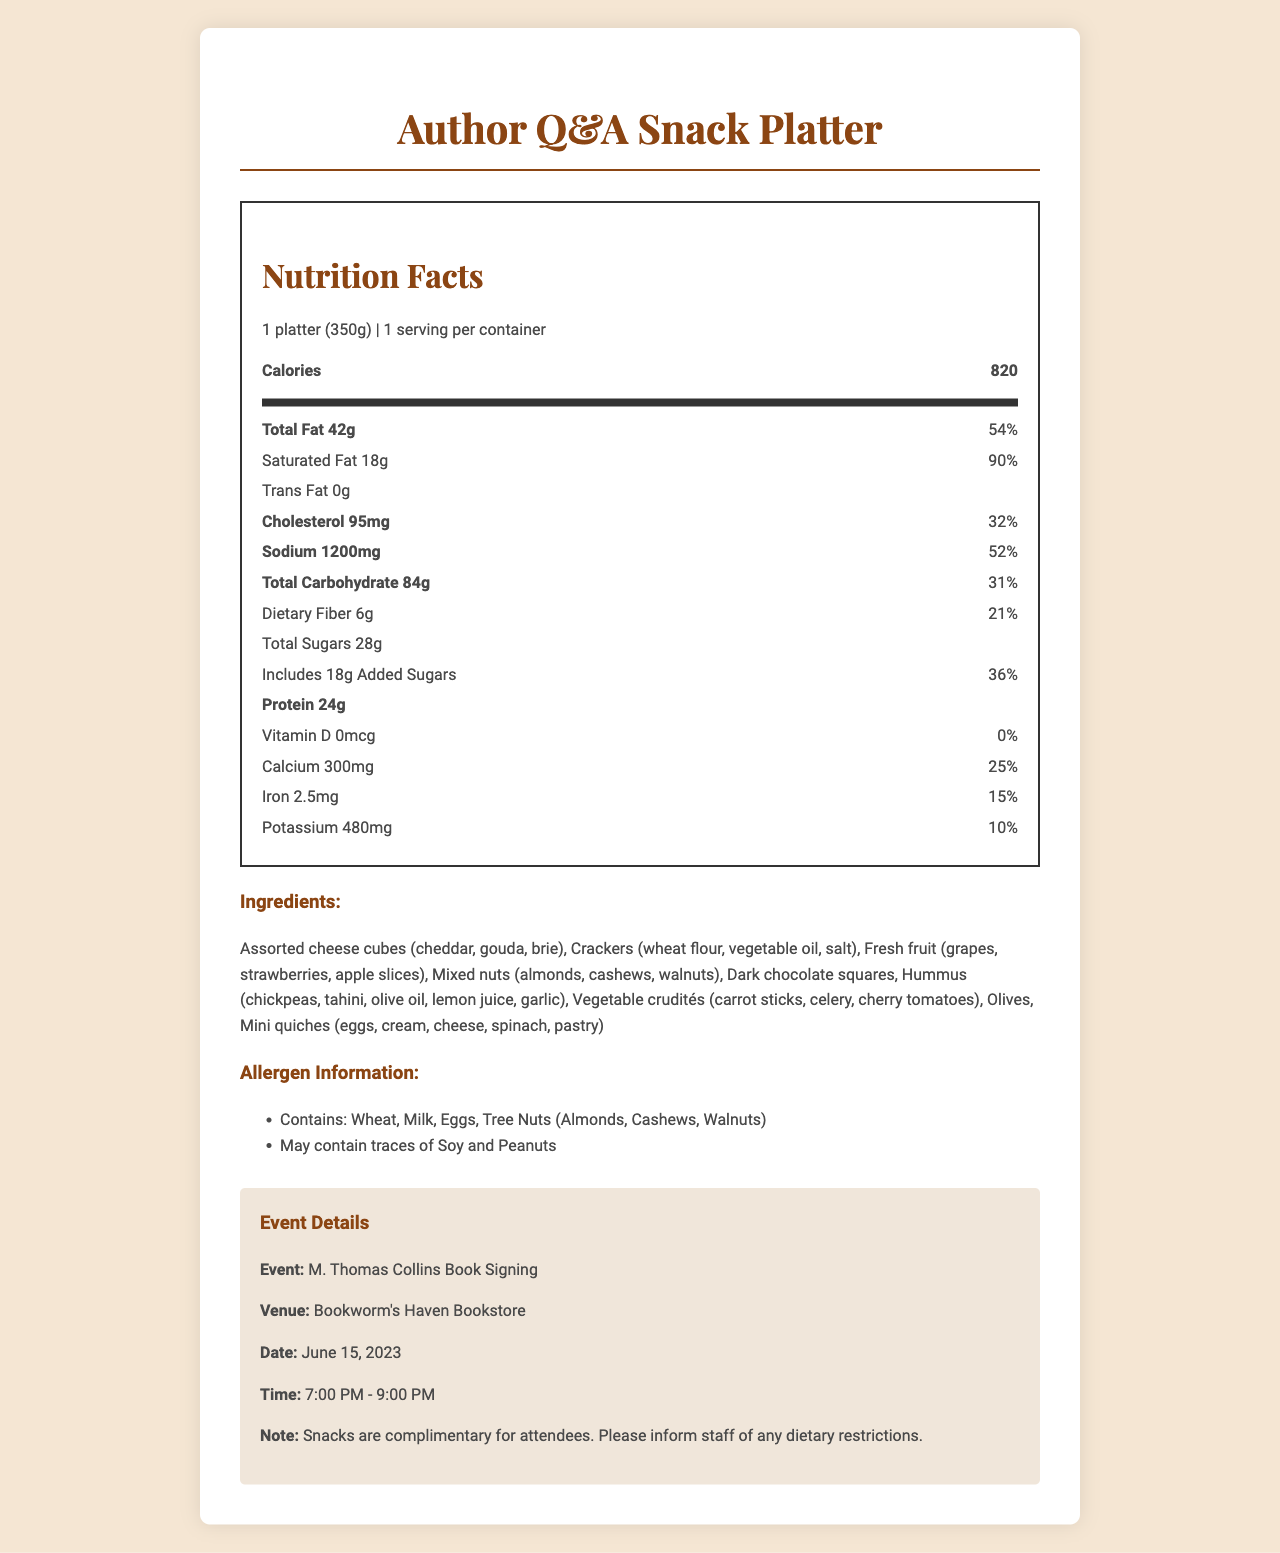what is the serving size of the snack platter? The serving size is stated as "1 platter (350g)" in the document.
Answer: 1 platter (350g) how many calories are in the Author Q&A Snack Platter? The calorie count is listed as 820 in the document.
Answer: 820 what is the amount of total fat in the platter? Under the nutrition facts, the total fat amount is specified as 42g.
Answer: 42g what allergens are present in the snack platter? The allergen information section lists these allergens.
Answer: Wheat, Milk, Eggs, Tree Nuts (Almonds, Cashews, Walnuts) what are the main ingredients in the snack platter? The ingredients section lists these items.
Answer: Assorted cheese cubes, Crackers, Fresh fruit, Mixed nuts, Dark chocolate squares, Hummus, Vegetable crudités, Olives, Mini quiches what event is associated with the snack platter? The event details section mentions the M. Thomas Collins Book Signing.
Answer: M. Thomas Collins Book Signing how much protein does the snack platter contain? The nutrition facts state that the protein content is 24g.
Answer: 24g what is the percentage daily value of sodium in the snack platter? The sodium daily value percentage is listed as 52%.
Answer: 52% how much added sugars are present in the snack platter? The document specifies 18g of added sugars in the nutrition facts.
Answer: 18g does the platter contain any trans fat? The nutrition facts state that the trans fat amount is 0g.
Answer: No (0g) how much dietary fiber does the platter provide? The dietary fiber amount is given as 6g in the nutrition facts.
Answer: 6g when is the M. Thomas Collins Book Signing event? The event details section mentions the date as June 15, 2023.
Answer: June 15, 2023 what is the total carbohydrate amount in the snack platter? In the nutrition facts, the total carbohydrate amount is listed as 84g.
Answer: 84g which of the following vitamins or minerals is not provided by the snack platter? A. Vitamin D B. Calcium C. Iron D. Potassium The document shows that Vitamin D is 0mcg (0% daily value), indicating it is not provided by the platter.
Answer: A. Vitamin D how many calories come from total fat based on the given nutrition facts? Using the formula (total fat grams * 9 calories/gram), the total fat (42g) amounts to 378 calories.
Answer: 378 calories which ingredient in the snack platter may cause allergic reactions due to tree nuts? The tree nuts listed in the ingredients section are in the mixed nuts.
Answer: Mixed nuts (almonds, cashews, walnuts) is there enough information to determine the exact recipe for mini quiches? The document lists the ingredients of the mini quiches but doesn’t provide the recipe.
Answer: No summarize the main purpose of the document. The summary captures the key points: nutritional information, ingredients, allergens, and event details, giving an overview of the entire document.
Answer: The document provides a detailed nutritional breakdown and ingredients list of the complimentary snack platter offered during the M. Thomas Collins Book Signing event. It includes information on allergens, event details, and a special note about dietary restrictions. what percentage of the daily value for calcium does the platter provide? A. 10% B. 15% C. 25% D. 36% The document states that the platter provides 25% of the daily value for calcium.
Answer: C. 25% what type of cheese is included in the assorted cheese cubes? The ingredients section lists cheddar, gouda, and brie as the types of cheese cubes included.
Answer: Cheddar, Gouda, Brie 